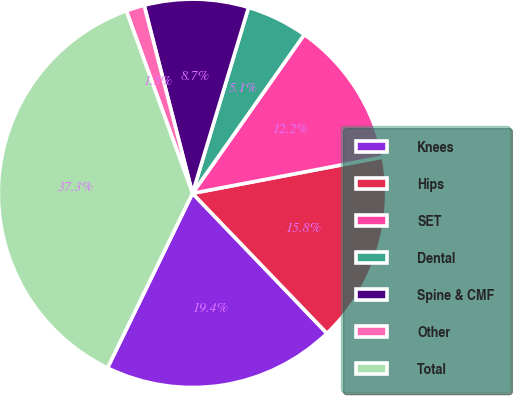Convert chart to OTSL. <chart><loc_0><loc_0><loc_500><loc_500><pie_chart><fcel>Knees<fcel>Hips<fcel>SET<fcel>Dental<fcel>Spine & CMF<fcel>Other<fcel>Total<nl><fcel>19.39%<fcel>15.82%<fcel>12.24%<fcel>5.1%<fcel>8.67%<fcel>1.53%<fcel>37.25%<nl></chart> 